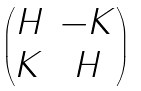<formula> <loc_0><loc_0><loc_500><loc_500>\begin{pmatrix} H & - K \\ K & H \end{pmatrix}</formula> 